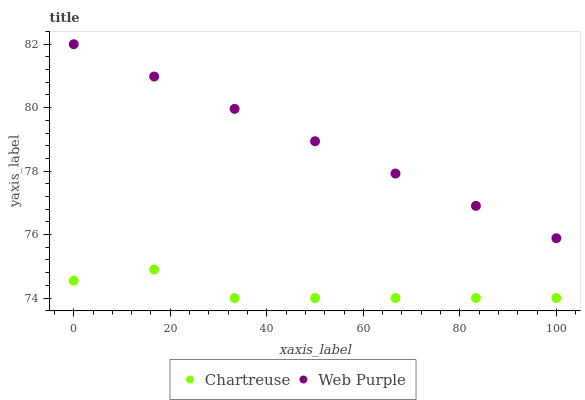Does Chartreuse have the minimum area under the curve?
Answer yes or no. Yes. Does Web Purple have the maximum area under the curve?
Answer yes or no. Yes. Does Web Purple have the minimum area under the curve?
Answer yes or no. No. Is Web Purple the smoothest?
Answer yes or no. Yes. Is Chartreuse the roughest?
Answer yes or no. Yes. Is Web Purple the roughest?
Answer yes or no. No. Does Chartreuse have the lowest value?
Answer yes or no. Yes. Does Web Purple have the lowest value?
Answer yes or no. No. Does Web Purple have the highest value?
Answer yes or no. Yes. Is Chartreuse less than Web Purple?
Answer yes or no. Yes. Is Web Purple greater than Chartreuse?
Answer yes or no. Yes. Does Chartreuse intersect Web Purple?
Answer yes or no. No. 